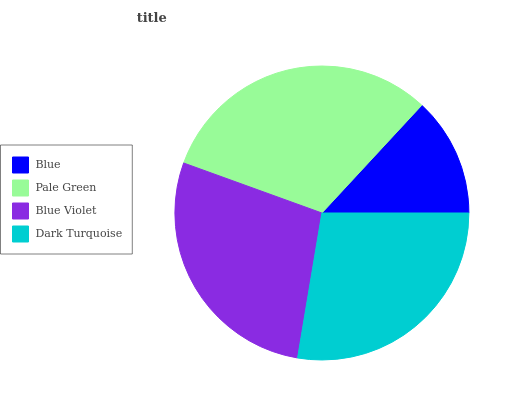Is Blue the minimum?
Answer yes or no. Yes. Is Pale Green the maximum?
Answer yes or no. Yes. Is Blue Violet the minimum?
Answer yes or no. No. Is Blue Violet the maximum?
Answer yes or no. No. Is Pale Green greater than Blue Violet?
Answer yes or no. Yes. Is Blue Violet less than Pale Green?
Answer yes or no. Yes. Is Blue Violet greater than Pale Green?
Answer yes or no. No. Is Pale Green less than Blue Violet?
Answer yes or no. No. Is Blue Violet the high median?
Answer yes or no. Yes. Is Dark Turquoise the low median?
Answer yes or no. Yes. Is Pale Green the high median?
Answer yes or no. No. Is Blue the low median?
Answer yes or no. No. 